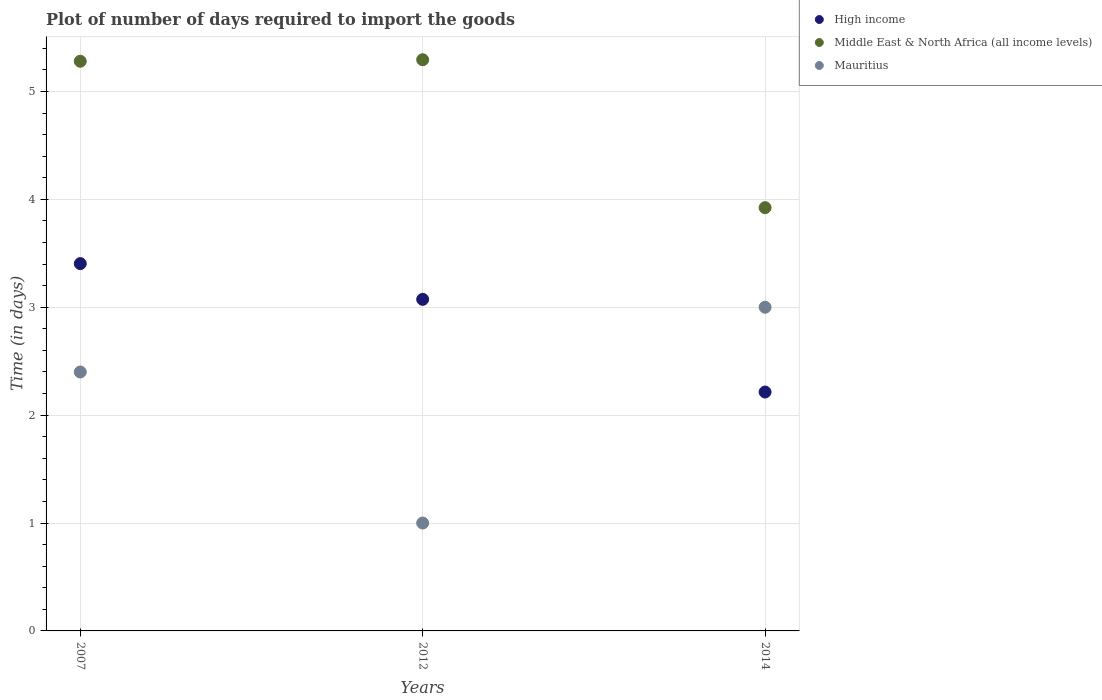Is the number of dotlines equal to the number of legend labels?
Provide a short and direct response. Yes. What is the time required to import goods in Middle East & North Africa (all income levels) in 2012?
Your response must be concise. 5.29. Across all years, what is the maximum time required to import goods in Middle East & North Africa (all income levels)?
Offer a very short reply. 5.29. Across all years, what is the minimum time required to import goods in High income?
Ensure brevity in your answer.  2.21. In which year was the time required to import goods in Mauritius maximum?
Provide a short and direct response. 2014. What is the total time required to import goods in Middle East & North Africa (all income levels) in the graph?
Your answer should be very brief. 14.5. What is the difference between the time required to import goods in Middle East & North Africa (all income levels) in 2007 and that in 2012?
Provide a succinct answer. -0.01. What is the difference between the time required to import goods in High income in 2014 and the time required to import goods in Mauritius in 2007?
Provide a short and direct response. -0.19. What is the average time required to import goods in High income per year?
Your answer should be very brief. 2.9. In the year 2012, what is the difference between the time required to import goods in High income and time required to import goods in Middle East & North Africa (all income levels)?
Ensure brevity in your answer.  -2.22. In how many years, is the time required to import goods in Middle East & North Africa (all income levels) greater than 3.4 days?
Provide a short and direct response. 3. What is the ratio of the time required to import goods in Middle East & North Africa (all income levels) in 2007 to that in 2014?
Make the answer very short. 1.35. Is the time required to import goods in Middle East & North Africa (all income levels) in 2007 less than that in 2014?
Offer a terse response. No. What is the difference between the highest and the second highest time required to import goods in High income?
Make the answer very short. 0.33. What is the difference between the highest and the lowest time required to import goods in High income?
Your response must be concise. 1.19. Is it the case that in every year, the sum of the time required to import goods in High income and time required to import goods in Middle East & North Africa (all income levels)  is greater than the time required to import goods in Mauritius?
Ensure brevity in your answer.  Yes. How many dotlines are there?
Your answer should be very brief. 3. Does the graph contain any zero values?
Keep it short and to the point. No. Does the graph contain grids?
Provide a short and direct response. Yes. How many legend labels are there?
Keep it short and to the point. 3. What is the title of the graph?
Keep it short and to the point. Plot of number of days required to import the goods. Does "Papua New Guinea" appear as one of the legend labels in the graph?
Offer a terse response. No. What is the label or title of the X-axis?
Your answer should be compact. Years. What is the label or title of the Y-axis?
Your answer should be very brief. Time (in days). What is the Time (in days) in High income in 2007?
Provide a succinct answer. 3.4. What is the Time (in days) of Middle East & North Africa (all income levels) in 2007?
Offer a terse response. 5.28. What is the Time (in days) of High income in 2012?
Make the answer very short. 3.07. What is the Time (in days) in Middle East & North Africa (all income levels) in 2012?
Offer a very short reply. 5.29. What is the Time (in days) of Mauritius in 2012?
Your answer should be compact. 1. What is the Time (in days) in High income in 2014?
Your response must be concise. 2.21. What is the Time (in days) in Middle East & North Africa (all income levels) in 2014?
Your response must be concise. 3.92. Across all years, what is the maximum Time (in days) of High income?
Offer a very short reply. 3.4. Across all years, what is the maximum Time (in days) in Middle East & North Africa (all income levels)?
Give a very brief answer. 5.29. Across all years, what is the maximum Time (in days) in Mauritius?
Your response must be concise. 3. Across all years, what is the minimum Time (in days) in High income?
Provide a short and direct response. 2.21. Across all years, what is the minimum Time (in days) of Middle East & North Africa (all income levels)?
Your response must be concise. 3.92. What is the total Time (in days) of High income in the graph?
Ensure brevity in your answer.  8.69. What is the total Time (in days) in Middle East & North Africa (all income levels) in the graph?
Offer a terse response. 14.5. What is the difference between the Time (in days) in High income in 2007 and that in 2012?
Offer a very short reply. 0.33. What is the difference between the Time (in days) of Middle East & North Africa (all income levels) in 2007 and that in 2012?
Keep it short and to the point. -0.01. What is the difference between the Time (in days) in High income in 2007 and that in 2014?
Make the answer very short. 1.19. What is the difference between the Time (in days) in Middle East & North Africa (all income levels) in 2007 and that in 2014?
Ensure brevity in your answer.  1.36. What is the difference between the Time (in days) in Mauritius in 2007 and that in 2014?
Keep it short and to the point. -0.6. What is the difference between the Time (in days) in High income in 2012 and that in 2014?
Give a very brief answer. 0.86. What is the difference between the Time (in days) of Middle East & North Africa (all income levels) in 2012 and that in 2014?
Your answer should be very brief. 1.37. What is the difference between the Time (in days) in Mauritius in 2012 and that in 2014?
Your response must be concise. -2. What is the difference between the Time (in days) in High income in 2007 and the Time (in days) in Middle East & North Africa (all income levels) in 2012?
Your response must be concise. -1.89. What is the difference between the Time (in days) of High income in 2007 and the Time (in days) of Mauritius in 2012?
Make the answer very short. 2.4. What is the difference between the Time (in days) of Middle East & North Africa (all income levels) in 2007 and the Time (in days) of Mauritius in 2012?
Your response must be concise. 4.28. What is the difference between the Time (in days) in High income in 2007 and the Time (in days) in Middle East & North Africa (all income levels) in 2014?
Provide a short and direct response. -0.52. What is the difference between the Time (in days) in High income in 2007 and the Time (in days) in Mauritius in 2014?
Your answer should be very brief. 0.4. What is the difference between the Time (in days) in Middle East & North Africa (all income levels) in 2007 and the Time (in days) in Mauritius in 2014?
Make the answer very short. 2.28. What is the difference between the Time (in days) of High income in 2012 and the Time (in days) of Middle East & North Africa (all income levels) in 2014?
Give a very brief answer. -0.85. What is the difference between the Time (in days) of High income in 2012 and the Time (in days) of Mauritius in 2014?
Offer a terse response. 0.07. What is the difference between the Time (in days) of Middle East & North Africa (all income levels) in 2012 and the Time (in days) of Mauritius in 2014?
Your answer should be very brief. 2.29. What is the average Time (in days) in High income per year?
Your answer should be compact. 2.9. What is the average Time (in days) in Middle East & North Africa (all income levels) per year?
Provide a short and direct response. 4.83. What is the average Time (in days) in Mauritius per year?
Make the answer very short. 2.13. In the year 2007, what is the difference between the Time (in days) of High income and Time (in days) of Middle East & North Africa (all income levels)?
Provide a succinct answer. -1.88. In the year 2007, what is the difference between the Time (in days) in Middle East & North Africa (all income levels) and Time (in days) in Mauritius?
Provide a succinct answer. 2.88. In the year 2012, what is the difference between the Time (in days) in High income and Time (in days) in Middle East & North Africa (all income levels)?
Give a very brief answer. -2.22. In the year 2012, what is the difference between the Time (in days) of High income and Time (in days) of Mauritius?
Your response must be concise. 2.07. In the year 2012, what is the difference between the Time (in days) of Middle East & North Africa (all income levels) and Time (in days) of Mauritius?
Provide a succinct answer. 4.29. In the year 2014, what is the difference between the Time (in days) in High income and Time (in days) in Middle East & North Africa (all income levels)?
Provide a succinct answer. -1.71. In the year 2014, what is the difference between the Time (in days) in High income and Time (in days) in Mauritius?
Offer a terse response. -0.79. In the year 2014, what is the difference between the Time (in days) in Middle East & North Africa (all income levels) and Time (in days) in Mauritius?
Provide a short and direct response. 0.92. What is the ratio of the Time (in days) of High income in 2007 to that in 2012?
Offer a very short reply. 1.11. What is the ratio of the Time (in days) of High income in 2007 to that in 2014?
Make the answer very short. 1.54. What is the ratio of the Time (in days) in Middle East & North Africa (all income levels) in 2007 to that in 2014?
Make the answer very short. 1.35. What is the ratio of the Time (in days) in High income in 2012 to that in 2014?
Your response must be concise. 1.39. What is the ratio of the Time (in days) in Middle East & North Africa (all income levels) in 2012 to that in 2014?
Give a very brief answer. 1.35. What is the ratio of the Time (in days) in Mauritius in 2012 to that in 2014?
Provide a short and direct response. 0.33. What is the difference between the highest and the second highest Time (in days) in High income?
Your answer should be compact. 0.33. What is the difference between the highest and the second highest Time (in days) of Middle East & North Africa (all income levels)?
Offer a very short reply. 0.01. What is the difference between the highest and the second highest Time (in days) of Mauritius?
Make the answer very short. 0.6. What is the difference between the highest and the lowest Time (in days) in High income?
Provide a short and direct response. 1.19. What is the difference between the highest and the lowest Time (in days) in Middle East & North Africa (all income levels)?
Keep it short and to the point. 1.37. 